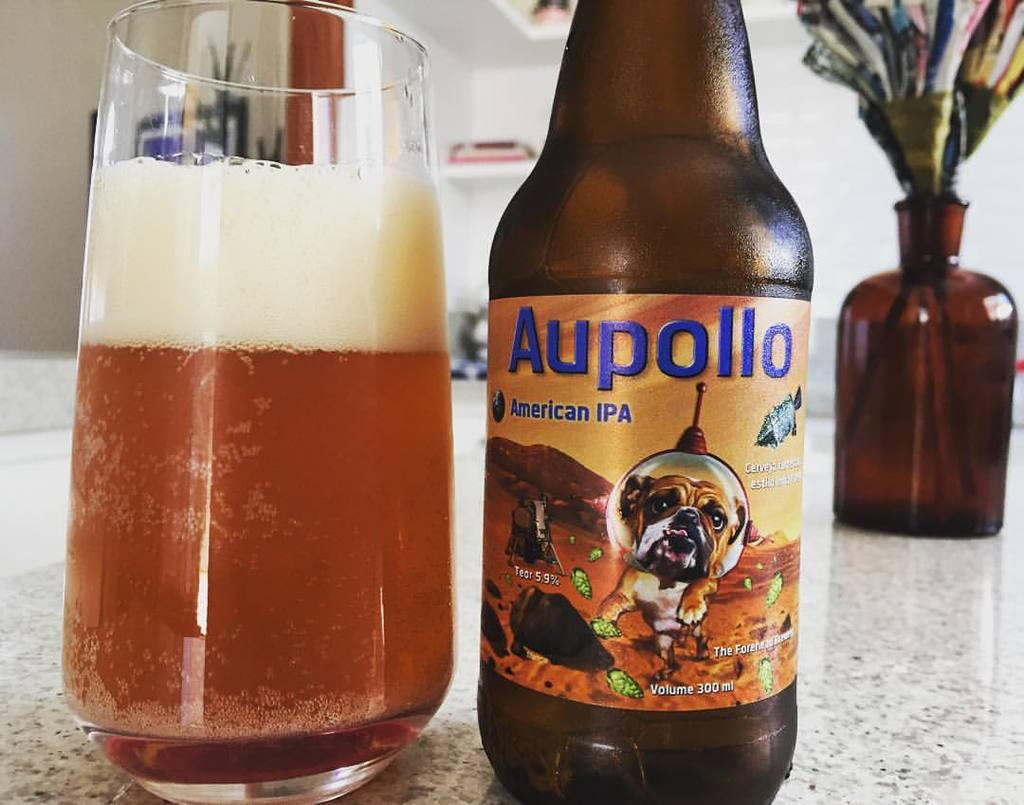Provide a one-sentence caption for the provided image. Half full glass sits on a counter next to a bottle of Aupollo. 